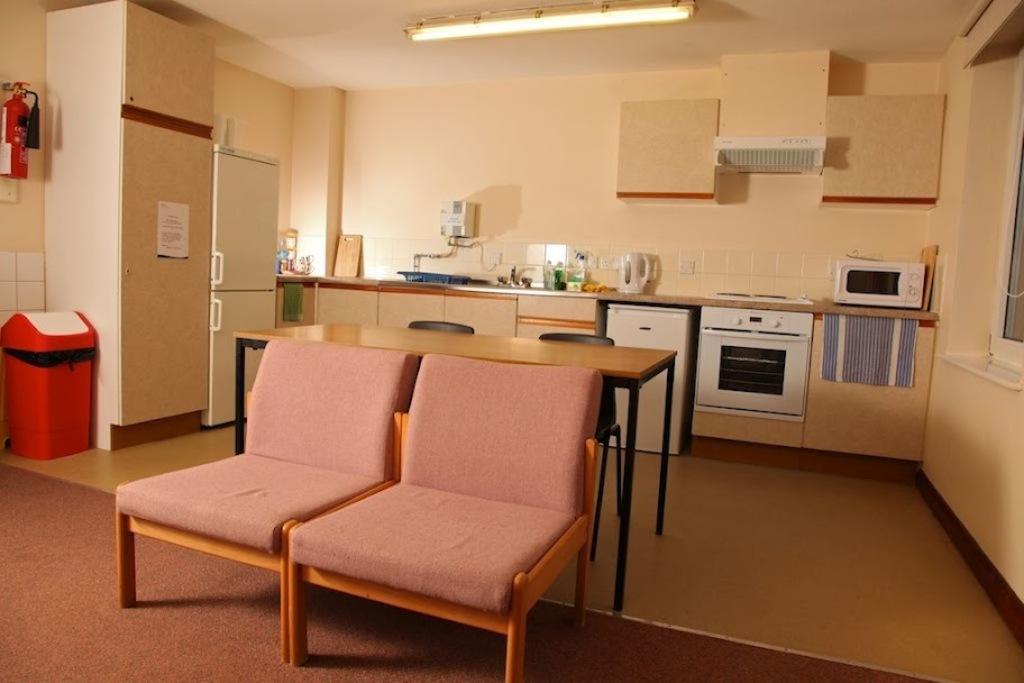How would you summarize this image in a sentence or two? In this image I can see few chairs, a refrigerator, a dustbin and a table. 